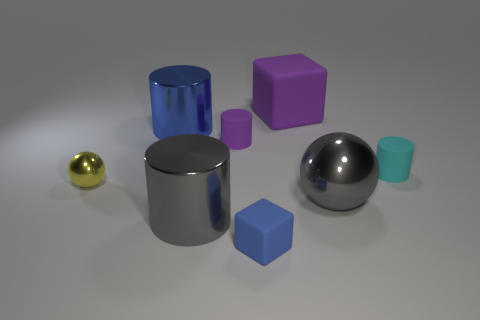There is a rubber block that is in front of the large gray metallic sphere; what number of cyan things are to the right of it?
Your answer should be very brief. 1. There is a large gray object that is right of the gray cylinder; does it have the same shape as the metal object behind the yellow ball?
Offer a very short reply. No. There is a blue matte object; what number of tiny purple matte cylinders are to the right of it?
Your answer should be compact. 0. Are the gray cylinder behind the tiny matte cube and the tiny blue block made of the same material?
Offer a terse response. No. What color is the other matte thing that is the same shape as the tiny cyan object?
Your answer should be very brief. Purple. The large blue shiny thing has what shape?
Offer a terse response. Cylinder. What number of objects are brown rubber balls or small things?
Your answer should be compact. 4. There is a large thing that is behind the blue metal object; does it have the same color as the ball that is to the left of the blue metallic thing?
Your answer should be compact. No. What number of other things are there of the same shape as the small cyan rubber thing?
Make the answer very short. 3. Are there any tiny brown shiny cubes?
Provide a short and direct response. No. 